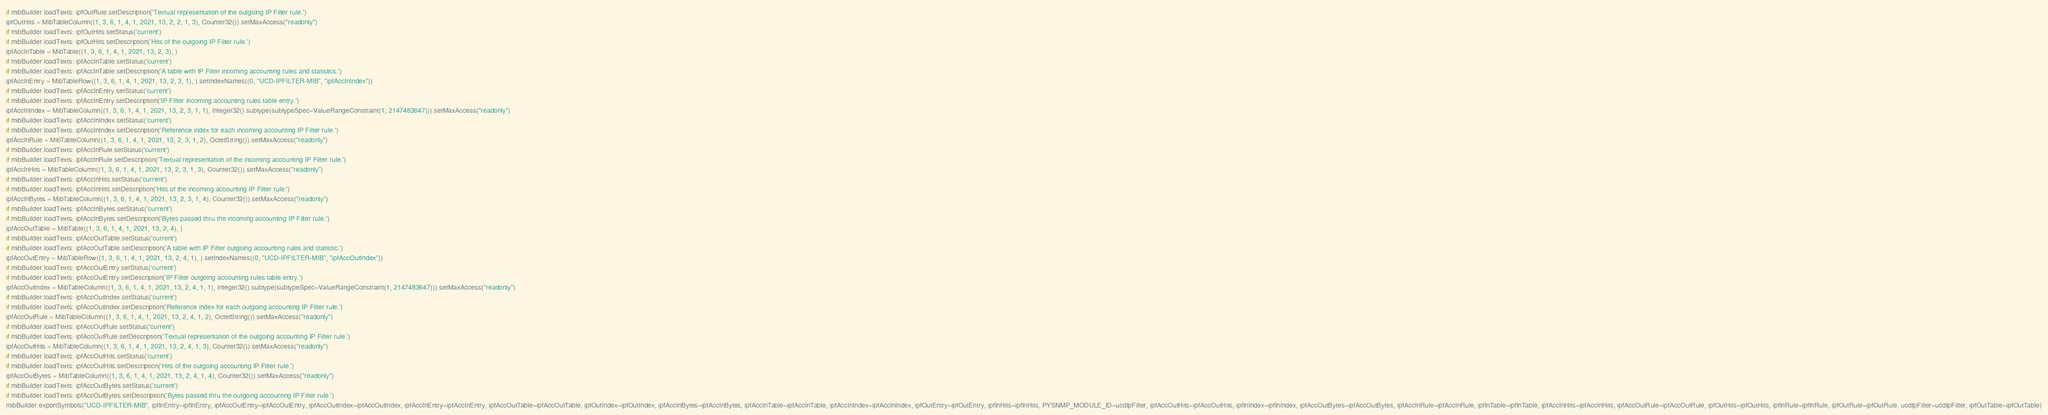<code> <loc_0><loc_0><loc_500><loc_500><_Python_>if mibBuilder.loadTexts: ipfOutRule.setDescription('Textual representation of the outgoing IP Filter rule.')
ipfOutHits = MibTableColumn((1, 3, 6, 1, 4, 1, 2021, 13, 2, 2, 1, 3), Counter32()).setMaxAccess("readonly")
if mibBuilder.loadTexts: ipfOutHits.setStatus('current')
if mibBuilder.loadTexts: ipfOutHits.setDescription('Hits of the outgoing IP Filter rule.')
ipfAccInTable = MibTable((1, 3, 6, 1, 4, 1, 2021, 13, 2, 3), )
if mibBuilder.loadTexts: ipfAccInTable.setStatus('current')
if mibBuilder.loadTexts: ipfAccInTable.setDescription('A table with IP Filter incoming accounting rules and statistics.')
ipfAccInEntry = MibTableRow((1, 3, 6, 1, 4, 1, 2021, 13, 2, 3, 1), ).setIndexNames((0, "UCD-IPFILTER-MIB", "ipfAccInIndex"))
if mibBuilder.loadTexts: ipfAccInEntry.setStatus('current')
if mibBuilder.loadTexts: ipfAccInEntry.setDescription('IP FIlter incoming accounting rules table entry.')
ipfAccInIndex = MibTableColumn((1, 3, 6, 1, 4, 1, 2021, 13, 2, 3, 1, 1), Integer32().subtype(subtypeSpec=ValueRangeConstraint(1, 2147483647))).setMaxAccess("readonly")
if mibBuilder.loadTexts: ipfAccInIndex.setStatus('current')
if mibBuilder.loadTexts: ipfAccInIndex.setDescription('Reference index for each incoming accounting IP Filter rule.')
ipfAccInRule = MibTableColumn((1, 3, 6, 1, 4, 1, 2021, 13, 2, 3, 1, 2), OctetString()).setMaxAccess("readonly")
if mibBuilder.loadTexts: ipfAccInRule.setStatus('current')
if mibBuilder.loadTexts: ipfAccInRule.setDescription('Textual representation of the incoming accounting IP Filter rule.')
ipfAccInHits = MibTableColumn((1, 3, 6, 1, 4, 1, 2021, 13, 2, 3, 1, 3), Counter32()).setMaxAccess("readonly")
if mibBuilder.loadTexts: ipfAccInHits.setStatus('current')
if mibBuilder.loadTexts: ipfAccInHits.setDescription('Hits of the incoming accounting IP Filter rule.')
ipfAccInBytes = MibTableColumn((1, 3, 6, 1, 4, 1, 2021, 13, 2, 3, 1, 4), Counter32()).setMaxAccess("readonly")
if mibBuilder.loadTexts: ipfAccInBytes.setStatus('current')
if mibBuilder.loadTexts: ipfAccInBytes.setDescription('Bytes passed thru the incoming accounting IP Filter rule.')
ipfAccOutTable = MibTable((1, 3, 6, 1, 4, 1, 2021, 13, 2, 4), )
if mibBuilder.loadTexts: ipfAccOutTable.setStatus('current')
if mibBuilder.loadTexts: ipfAccOutTable.setDescription('A table with IP Filter outgoing accounting rules and statistic.')
ipfAccOutEntry = MibTableRow((1, 3, 6, 1, 4, 1, 2021, 13, 2, 4, 1), ).setIndexNames((0, "UCD-IPFILTER-MIB", "ipfAccOutIndex"))
if mibBuilder.loadTexts: ipfAccOutEntry.setStatus('current')
if mibBuilder.loadTexts: ipfAccOutEntry.setDescription('IP Filter outgoing accounting rules table entry.')
ipfAccOutIndex = MibTableColumn((1, 3, 6, 1, 4, 1, 2021, 13, 2, 4, 1, 1), Integer32().subtype(subtypeSpec=ValueRangeConstraint(1, 2147483647))).setMaxAccess("readonly")
if mibBuilder.loadTexts: ipfAccOutIndex.setStatus('current')
if mibBuilder.loadTexts: ipfAccOutIndex.setDescription('Reference index for each outgoing accounting IP Filter rule.')
ipfAccOutRule = MibTableColumn((1, 3, 6, 1, 4, 1, 2021, 13, 2, 4, 1, 2), OctetString()).setMaxAccess("readonly")
if mibBuilder.loadTexts: ipfAccOutRule.setStatus('current')
if mibBuilder.loadTexts: ipfAccOutRule.setDescription('Textual representation of the outgoing accounting IP Filter rule.')
ipfAccOutHits = MibTableColumn((1, 3, 6, 1, 4, 1, 2021, 13, 2, 4, 1, 3), Counter32()).setMaxAccess("readonly")
if mibBuilder.loadTexts: ipfAccOutHits.setStatus('current')
if mibBuilder.loadTexts: ipfAccOutHits.setDescription('Hits of the outgoing accounting IP Filter rule.')
ipfAccOutBytes = MibTableColumn((1, 3, 6, 1, 4, 1, 2021, 13, 2, 4, 1, 4), Counter32()).setMaxAccess("readonly")
if mibBuilder.loadTexts: ipfAccOutBytes.setStatus('current')
if mibBuilder.loadTexts: ipfAccOutBytes.setDescription('Bytes passed thru the outgoing accounting IP Filter rule.')
mibBuilder.exportSymbols("UCD-IPFILTER-MIB", ipfInEntry=ipfInEntry, ipfAccOutEntry=ipfAccOutEntry, ipfAccOutIndex=ipfAccOutIndex, ipfAccInEntry=ipfAccInEntry, ipfAccOutTable=ipfAccOutTable, ipfOutIndex=ipfOutIndex, ipfAccInBytes=ipfAccInBytes, ipfAccInTable=ipfAccInTable, ipfAccInIndex=ipfAccInIndex, ipfOutEntry=ipfOutEntry, ipfInHits=ipfInHits, PYSNMP_MODULE_ID=ucdIpFilter, ipfAccOutHits=ipfAccOutHits, ipfInIndex=ipfInIndex, ipfAccOutBytes=ipfAccOutBytes, ipfAccInRule=ipfAccInRule, ipfInTable=ipfInTable, ipfAccInHits=ipfAccInHits, ipfAccOutRule=ipfAccOutRule, ipfOutHits=ipfOutHits, ipfInRule=ipfInRule, ipfOutRule=ipfOutRule, ucdIpFilter=ucdIpFilter, ipfOutTable=ipfOutTable)
</code> 